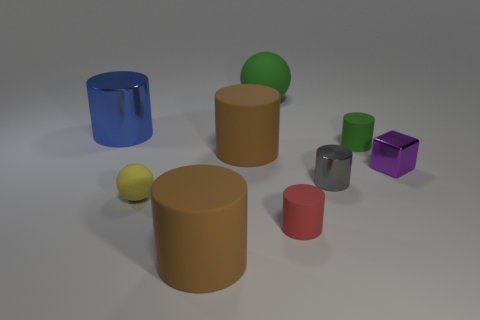Subtract all big blue cylinders. How many cylinders are left? 5 Subtract all brown cylinders. How many cylinders are left? 4 Subtract 2 spheres. How many spheres are left? 0 Add 1 big blue rubber blocks. How many objects exist? 10 Subtract all blocks. How many objects are left? 8 Subtract all brown cylinders. Subtract all green balls. How many cylinders are left? 4 Subtract all gray spheres. How many purple cylinders are left? 0 Subtract all small gray shiny objects. Subtract all blue things. How many objects are left? 7 Add 4 large green matte objects. How many large green matte objects are left? 5 Add 1 green cylinders. How many green cylinders exist? 2 